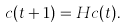Convert formula to latex. <formula><loc_0><loc_0><loc_500><loc_500>c ( t + 1 ) = H c ( t ) .</formula> 